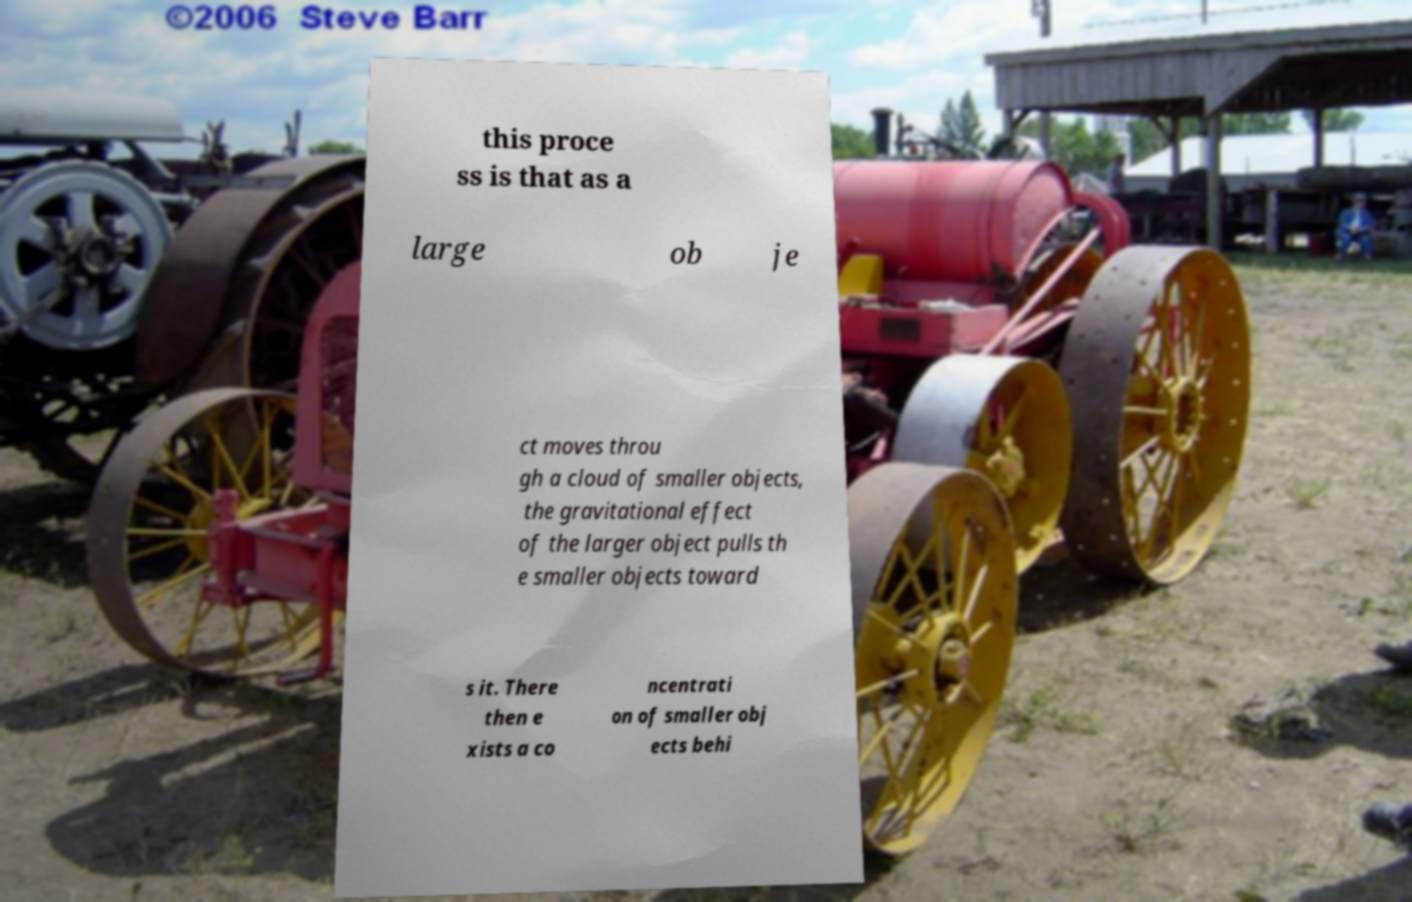Please identify and transcribe the text found in this image. this proce ss is that as a large ob je ct moves throu gh a cloud of smaller objects, the gravitational effect of the larger object pulls th e smaller objects toward s it. There then e xists a co ncentrati on of smaller obj ects behi 